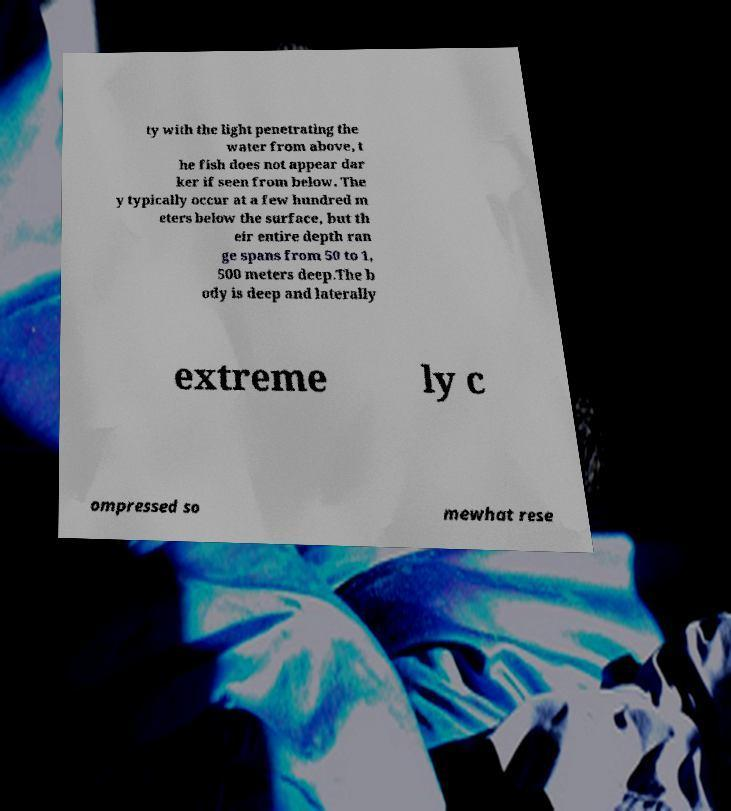Could you assist in decoding the text presented in this image and type it out clearly? ty with the light penetrating the water from above, t he fish does not appear dar ker if seen from below. The y typically occur at a few hundred m eters below the surface, but th eir entire depth ran ge spans from 50 to 1, 500 meters deep.The b ody is deep and laterally extreme ly c ompressed so mewhat rese 